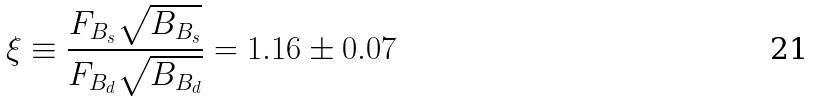<formula> <loc_0><loc_0><loc_500><loc_500>\xi \equiv \frac { F _ { B _ { s } } \sqrt { B _ { B _ { s } } } } { F _ { B _ { d } } \sqrt { B _ { B _ { d } } } } = 1 . 1 6 \pm 0 . 0 7</formula> 